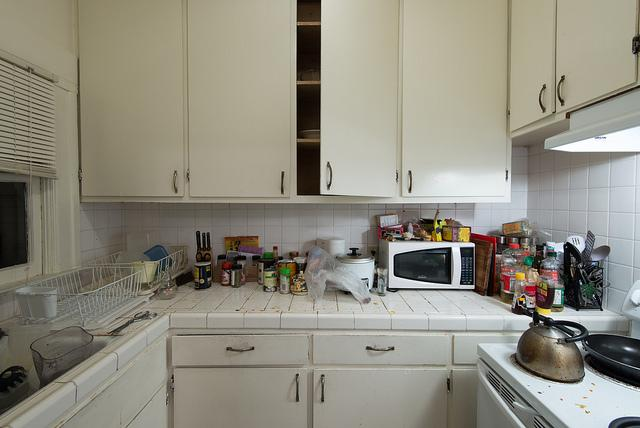Why is there a dish drainer on the counter? dry dishes 